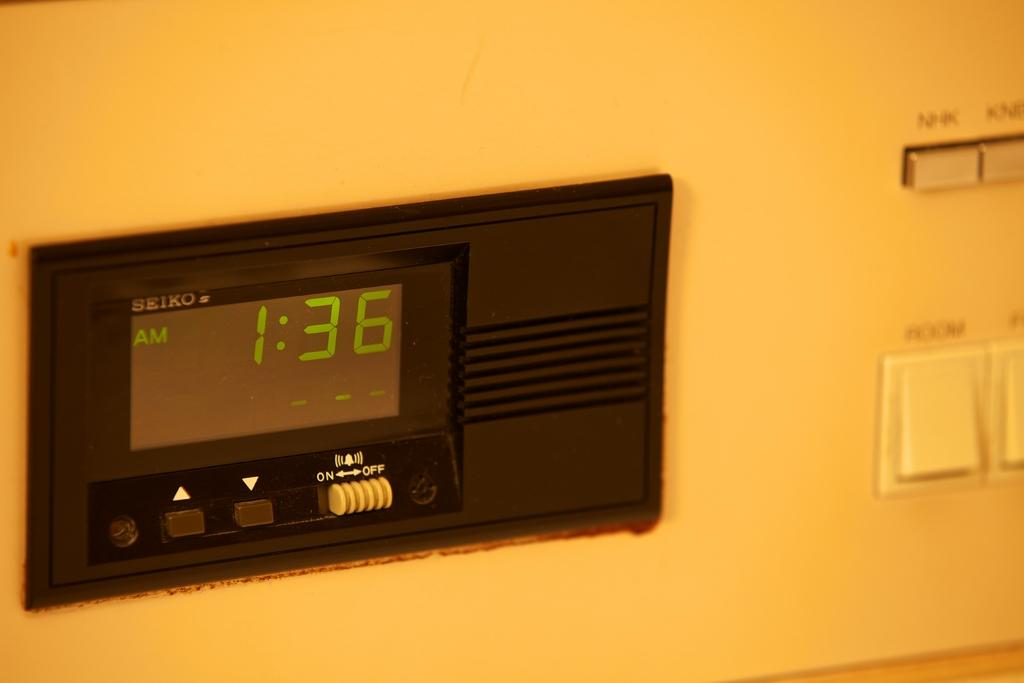<image>
Give a short and clear explanation of the subsequent image. Seiko digital clock that reads  1:36AM and has an on and off button. 